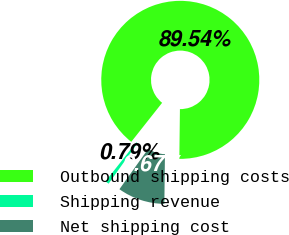Convert chart. <chart><loc_0><loc_0><loc_500><loc_500><pie_chart><fcel>Outbound shipping costs<fcel>Shipping revenue<fcel>Net shipping cost<nl><fcel>89.54%<fcel>0.79%<fcel>9.67%<nl></chart> 